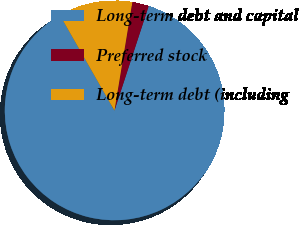<chart> <loc_0><loc_0><loc_500><loc_500><pie_chart><fcel>Long-term debt and capital<fcel>Preferred stock<fcel>Long-term debt (including<nl><fcel>86.7%<fcel>2.44%<fcel>10.86%<nl></chart> 